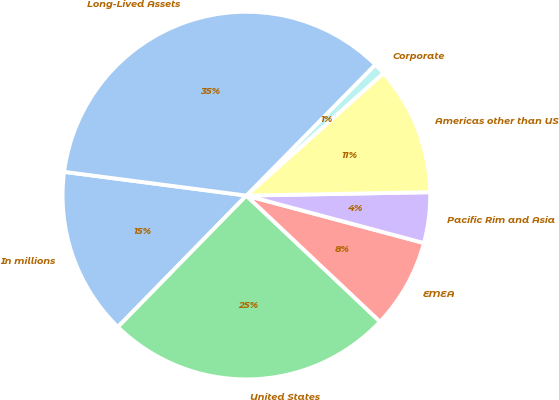<chart> <loc_0><loc_0><loc_500><loc_500><pie_chart><fcel>In millions<fcel>United States<fcel>EMEA<fcel>Pacific Rim and Asia<fcel>Americas other than US<fcel>Corporate<fcel>Long-Lived Assets<nl><fcel>14.74%<fcel>25.28%<fcel>7.88%<fcel>4.45%<fcel>11.31%<fcel>1.02%<fcel>35.31%<nl></chart> 